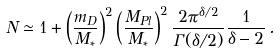<formula> <loc_0><loc_0><loc_500><loc_500>N \simeq 1 + \left ( \frac { m _ { D } } { M _ { * } } \right ) ^ { 2 } \left ( \frac { M _ { P l } } { M _ { * } } \right ) ^ { 2 } \frac { 2 \pi ^ { \delta / 2 } } { \Gamma ( \delta / 2 ) } \frac { 1 } { \delta - 2 } \, .</formula> 